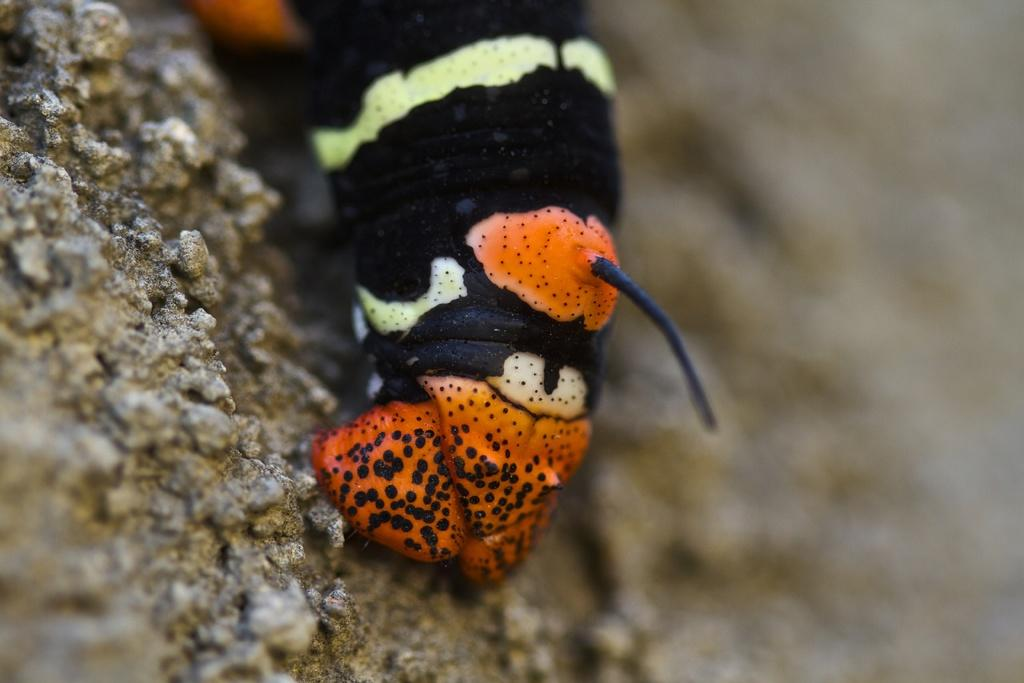What type of creature is in the image? There is an insect in the image. What colors can be seen on the insect? The insect has yellow, black, and orange coloring. What is the insect's environment in the image? The insect is on a rocky surface. What colors are present on the rocky surface? The rocky surface is brown and cream in color. What verse from the Bible is being recited by the insect in the image? There is no indication in the image that the insect is reciting a verse from the Bible, as insects do not have the ability to speak or recite verses. 